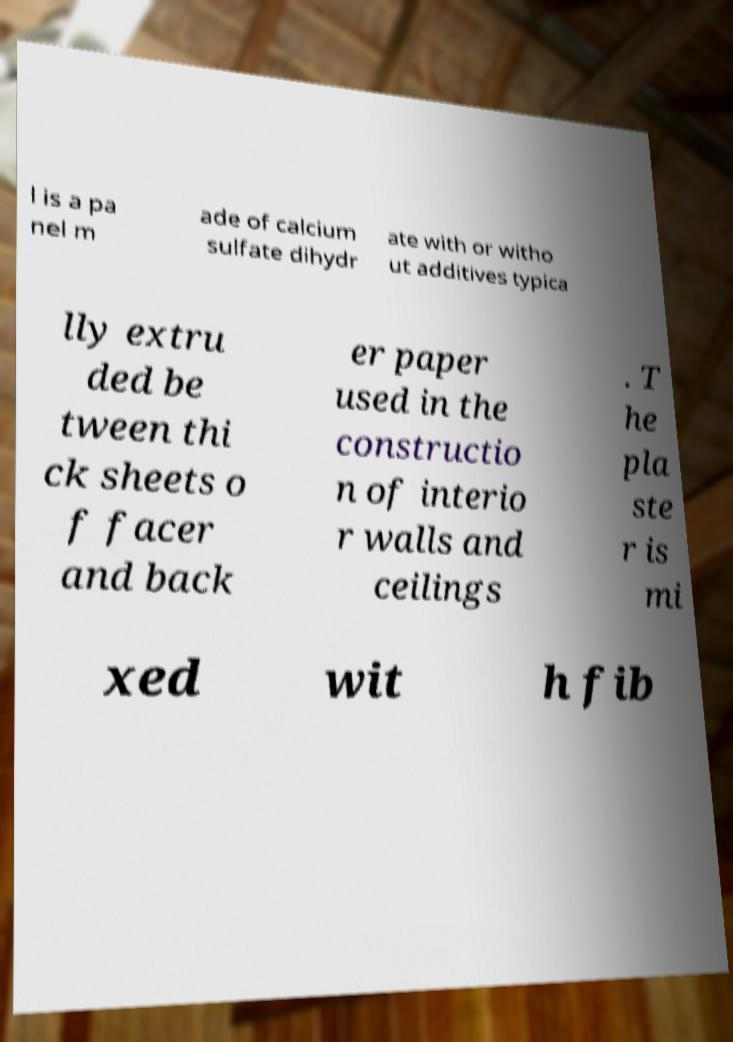Could you assist in decoding the text presented in this image and type it out clearly? l is a pa nel m ade of calcium sulfate dihydr ate with or witho ut additives typica lly extru ded be tween thi ck sheets o f facer and back er paper used in the constructio n of interio r walls and ceilings . T he pla ste r is mi xed wit h fib 